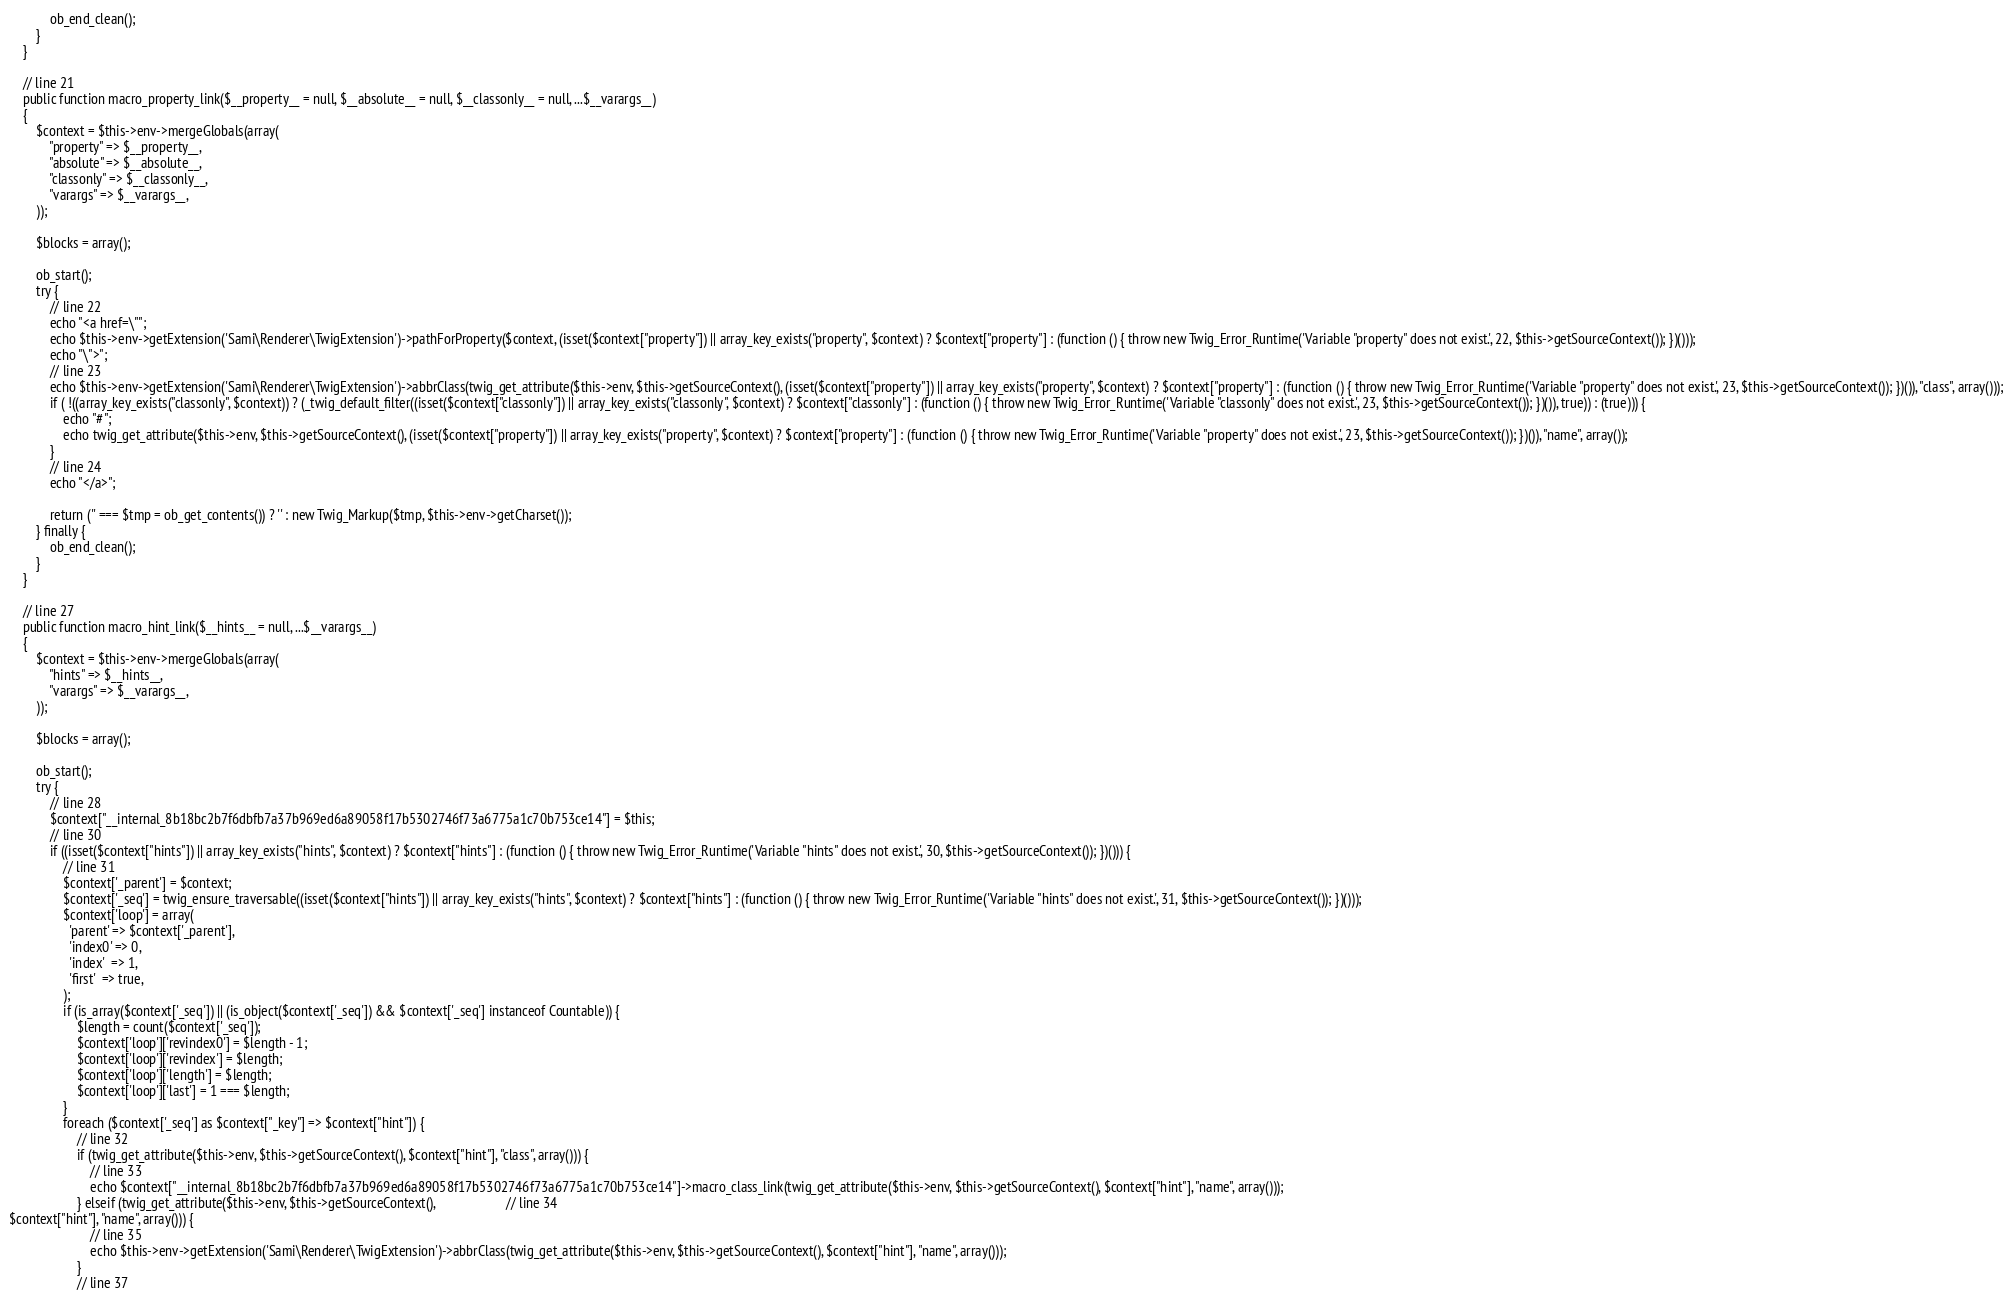<code> <loc_0><loc_0><loc_500><loc_500><_PHP_>            ob_end_clean();
        }
    }

    // line 21
    public function macro_property_link($__property__ = null, $__absolute__ = null, $__classonly__ = null, ...$__varargs__)
    {
        $context = $this->env->mergeGlobals(array(
            "property" => $__property__,
            "absolute" => $__absolute__,
            "classonly" => $__classonly__,
            "varargs" => $__varargs__,
        ));

        $blocks = array();

        ob_start();
        try {
            // line 22
            echo "<a href=\"";
            echo $this->env->getExtension('Sami\Renderer\TwigExtension')->pathForProperty($context, (isset($context["property"]) || array_key_exists("property", $context) ? $context["property"] : (function () { throw new Twig_Error_Runtime('Variable "property" does not exist.', 22, $this->getSourceContext()); })()));
            echo "\">";
            // line 23
            echo $this->env->getExtension('Sami\Renderer\TwigExtension')->abbrClass(twig_get_attribute($this->env, $this->getSourceContext(), (isset($context["property"]) || array_key_exists("property", $context) ? $context["property"] : (function () { throw new Twig_Error_Runtime('Variable "property" does not exist.', 23, $this->getSourceContext()); })()), "class", array()));
            if ( !((array_key_exists("classonly", $context)) ? (_twig_default_filter((isset($context["classonly"]) || array_key_exists("classonly", $context) ? $context["classonly"] : (function () { throw new Twig_Error_Runtime('Variable "classonly" does not exist.', 23, $this->getSourceContext()); })()), true)) : (true))) {
                echo "#";
                echo twig_get_attribute($this->env, $this->getSourceContext(), (isset($context["property"]) || array_key_exists("property", $context) ? $context["property"] : (function () { throw new Twig_Error_Runtime('Variable "property" does not exist.', 23, $this->getSourceContext()); })()), "name", array());
            }
            // line 24
            echo "</a>";

            return ('' === $tmp = ob_get_contents()) ? '' : new Twig_Markup($tmp, $this->env->getCharset());
        } finally {
            ob_end_clean();
        }
    }

    // line 27
    public function macro_hint_link($__hints__ = null, ...$__varargs__)
    {
        $context = $this->env->mergeGlobals(array(
            "hints" => $__hints__,
            "varargs" => $__varargs__,
        ));

        $blocks = array();

        ob_start();
        try {
            // line 28
            $context["__internal_8b18bc2b7f6dbfb7a37b969ed6a89058f17b5302746f73a6775a1c70b753ce14"] = $this;
            // line 30
            if ((isset($context["hints"]) || array_key_exists("hints", $context) ? $context["hints"] : (function () { throw new Twig_Error_Runtime('Variable "hints" does not exist.', 30, $this->getSourceContext()); })())) {
                // line 31
                $context['_parent'] = $context;
                $context['_seq'] = twig_ensure_traversable((isset($context["hints"]) || array_key_exists("hints", $context) ? $context["hints"] : (function () { throw new Twig_Error_Runtime('Variable "hints" does not exist.', 31, $this->getSourceContext()); })()));
                $context['loop'] = array(
                  'parent' => $context['_parent'],
                  'index0' => 0,
                  'index'  => 1,
                  'first'  => true,
                );
                if (is_array($context['_seq']) || (is_object($context['_seq']) && $context['_seq'] instanceof Countable)) {
                    $length = count($context['_seq']);
                    $context['loop']['revindex0'] = $length - 1;
                    $context['loop']['revindex'] = $length;
                    $context['loop']['length'] = $length;
                    $context['loop']['last'] = 1 === $length;
                }
                foreach ($context['_seq'] as $context["_key"] => $context["hint"]) {
                    // line 32
                    if (twig_get_attribute($this->env, $this->getSourceContext(), $context["hint"], "class", array())) {
                        // line 33
                        echo $context["__internal_8b18bc2b7f6dbfb7a37b969ed6a89058f17b5302746f73a6775a1c70b753ce14"]->macro_class_link(twig_get_attribute($this->env, $this->getSourceContext(), $context["hint"], "name", array()));
                    } elseif (twig_get_attribute($this->env, $this->getSourceContext(),                     // line 34
$context["hint"], "name", array())) {
                        // line 35
                        echo $this->env->getExtension('Sami\Renderer\TwigExtension')->abbrClass(twig_get_attribute($this->env, $this->getSourceContext(), $context["hint"], "name", array()));
                    }
                    // line 37</code> 